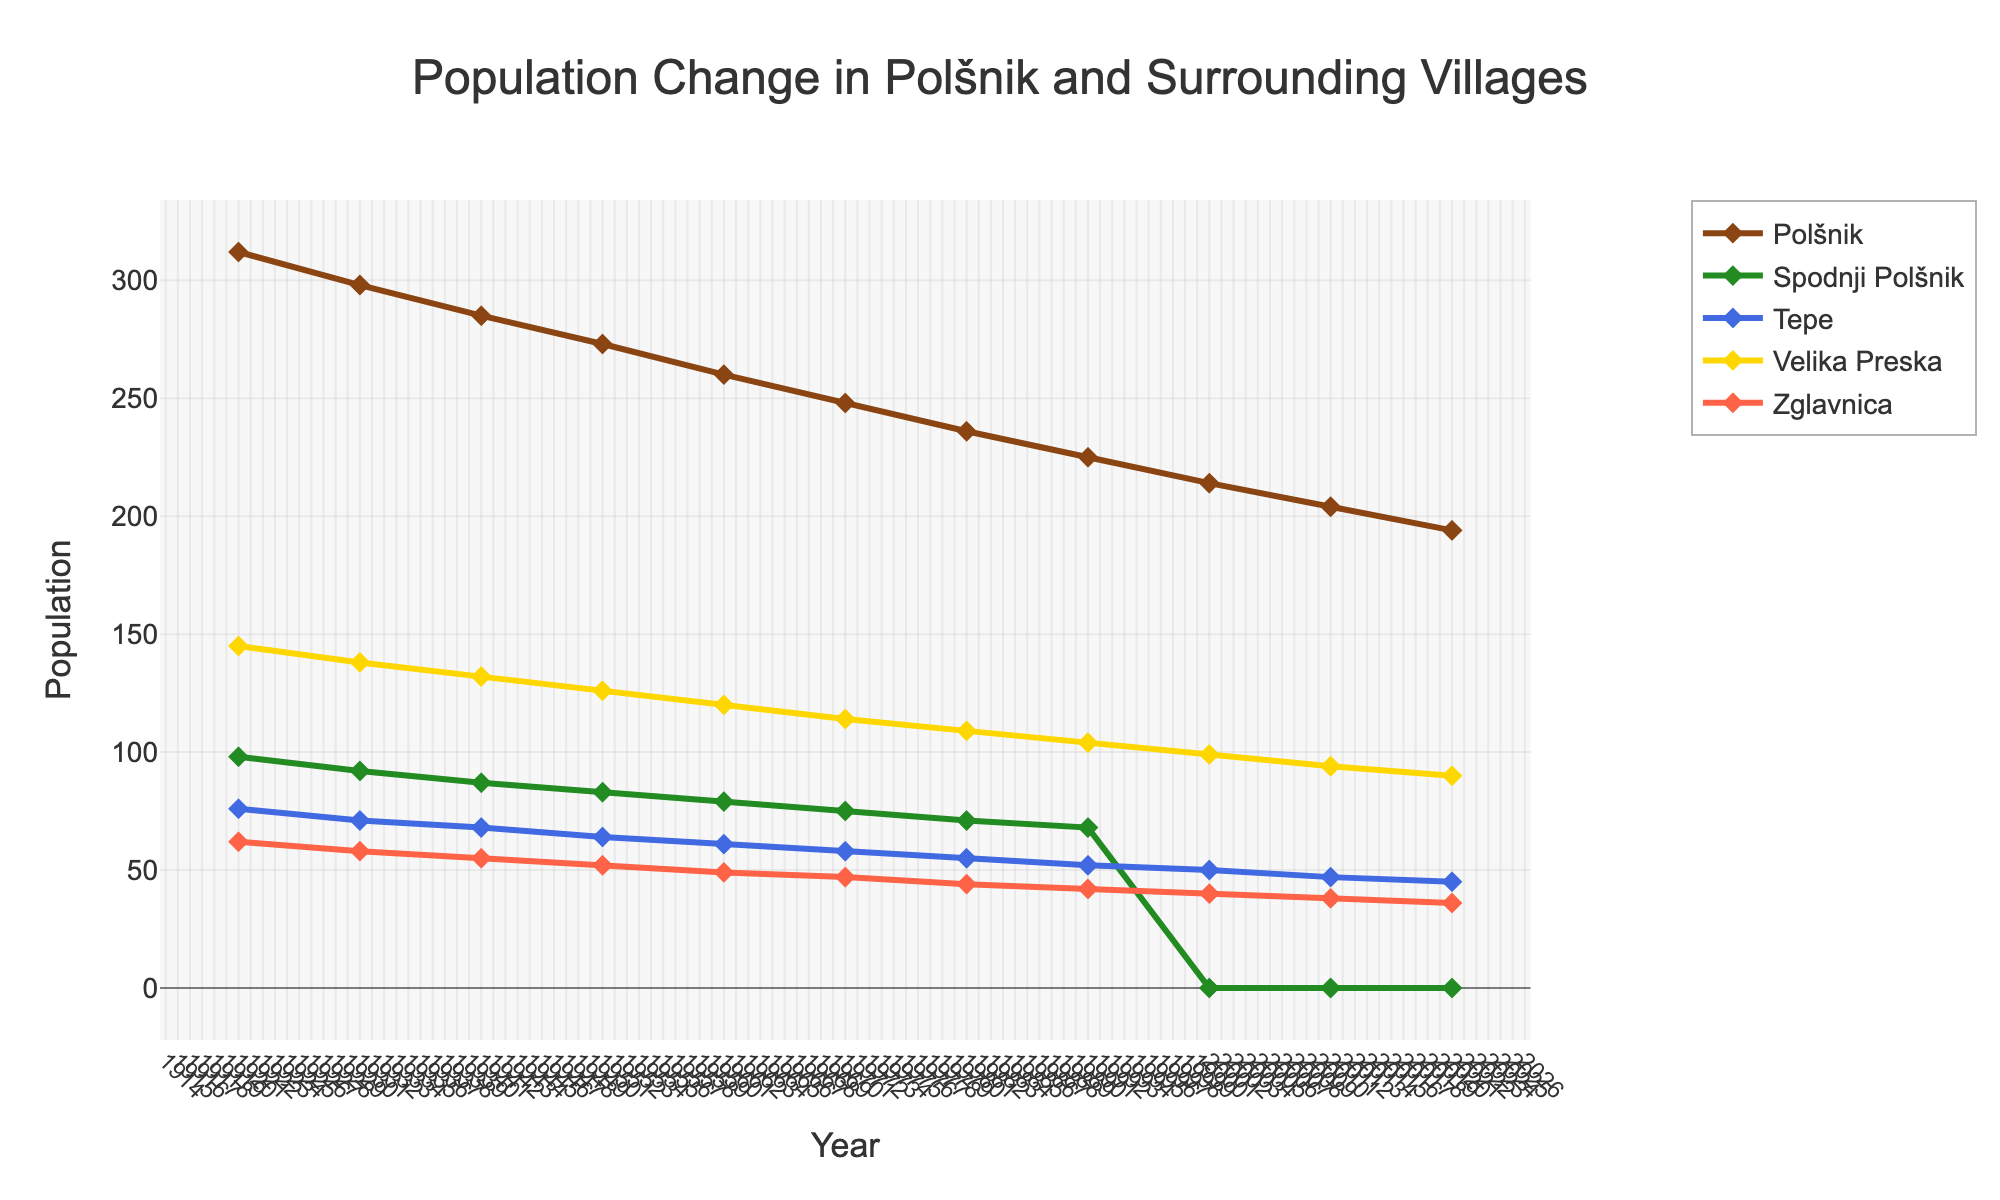Which village had the highest population in 1920? To find the answer, look at the data points for the year 1920. The village with the highest population that year was Polšnik with 312 residents.
Answer: Polšnik What was the population difference between Polšnik and Velika Preska in 1930? Subtract the population of Velika Preska from Polšnik in 1930. Polšnik had 298 residents, and Velika Preska had 138 residents. The difference is 298 - 138 = 160.
Answer: 160 Which village had the most significant population drop between 1960 and 1970? Examine the difference in population for all villages between 1960 and 1970. Polšnik went from 260 to 248 (a drop of 12), Spodnji Polšnik went from 79 to 75 (a drop of 4), Tepe went from 61 to 58 (a drop of 3), Velika Preska went from 120 to 114 (a drop of 6), and Zglavnica went from 49 to 47 (a drop of 2). The largest drop occurred in Polšnik.
Answer: Polšnik During which decade did Velika Preska experience the most significant population decline? Calculate the population change for each decade for Velika Preska. 1930-1940: 138-132=6, 1940-1950: 132-126=6, 1950-1960: 126-120=6, 1960-1970: 120-114=6, 1970-1980: 114-109=5, 1980-1990: 109-104=5, 1990-2000: 104-99=5, 2000-2010: 99-94=5, 2010-2020: 94-90=4. The most significant declines occurred across the span of multiple decades where every marked instance was a reduction in increments of 6. Thus the periods 1930-1960 saw the most decline in Velika Preska.
Answer: 1930-1960 How many total residents were there in Tepe over the entire century? Sum the population numbers for Tepe for all given decades: 76+71+68+64+61+58+55+52+50+47+45 = 647.
Answer: 647 Which village's population lines are represented by green and blue colors, respectively? Check the colors associated with each village’s line. The village represented by green is Spodnji Polšnik and the one by blue is Tepe.
Answer: Spodnji Polšnik and Tepe What is the average population of Zglavnica between 1920 and 2020? Sum the population numbers for Zglavnica and divide by the number of decades: (62+58+55+52+49+47+44+42+40+38+36) / 11 = 473 / 11 ≈ 43.
Answer: 43 In which year did Spodnji Polšnik merge, showing zero population afterward? Identify the year when the population of Spodnji Polšnik became zero, indicating its merge. The value became zero in 2000.
Answer: 2000 By how much did the population of Polšnik decrease from 1920 to 2020? Subtract the 2020 population of Polšnik (194) from the 1920 population (312). The decrease is 312 - 194 = 118.
Answer: 118 Which village had the smallest population change from 1940 to 1950? Compare the population change for each village between 1940 and 1950. The changes are Polšnik: 285-273=12, Spodnji Polšnik: 87-83=4, Tepe: 68-64=4, Velika Preska: 132-126=6, Zglavnica: 55-52=3. The smallest change occurred in Zglavnica.
Answer: Zglavnica 